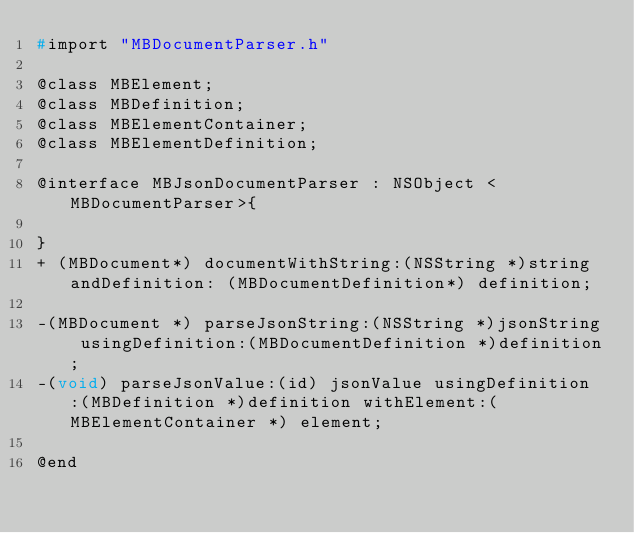<code> <loc_0><loc_0><loc_500><loc_500><_C_>#import "MBDocumentParser.h"

@class MBElement;
@class MBDefinition;
@class MBElementContainer;
@class MBElementDefinition;

@interface MBJsonDocumentParser : NSObject <MBDocumentParser>{

}
+ (MBDocument*) documentWithString:(NSString *)string andDefinition: (MBDocumentDefinition*) definition;

-(MBDocument *) parseJsonString:(NSString *)jsonString usingDefinition:(MBDocumentDefinition *)definition;
-(void) parseJsonValue:(id) jsonValue usingDefinition:(MBDefinition *)definition withElement:(MBElementContainer *) element;

@end
</code> 